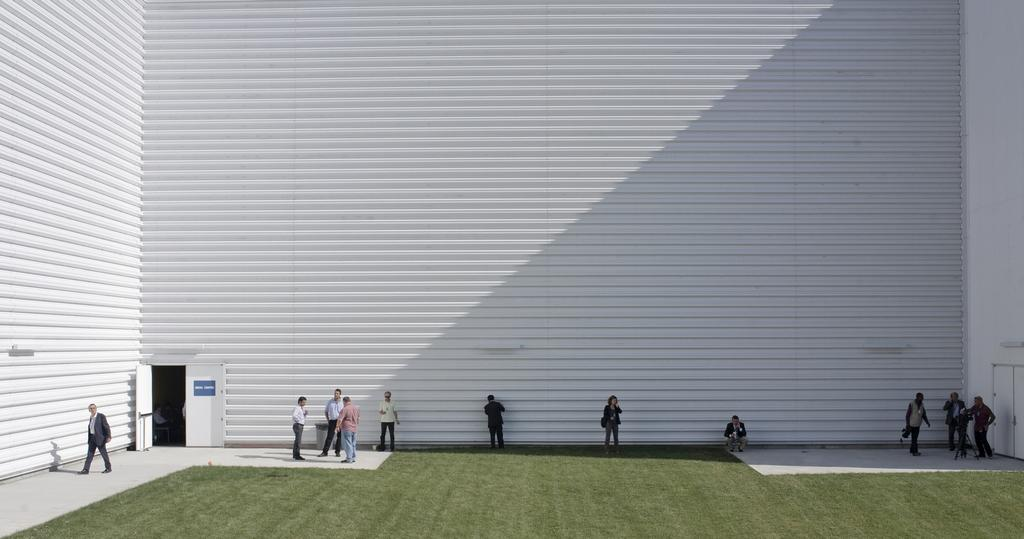Who or what can be seen at the bottom of the image? There are persons at the bottom of the image. What type of surface is at the bottom of the image? There is grass at the bottom of the image. What architectural feature is present at the bottom of the image? There is a door at the bottom of the image. What can be seen in the background of the image? There is a wall in the background of the image. What type of produce is being discussed in the meeting at the bottom of the image? There is no meeting present in the image, and therefore no discussion about produce can be observed. Can you describe the toes of the persons at the bottom of the image? There is no mention of toes in the image, and therefore it cannot be described. 